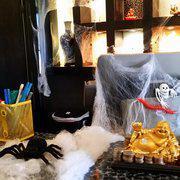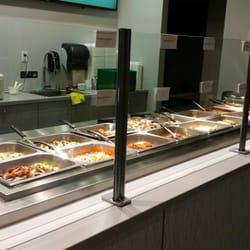The first image is the image on the left, the second image is the image on the right. Examine the images to the left and right. Is the description "The right image shows tongs by rows of steel bins full of food, and the left image includes a white food plate surrounded by other dishware items on a dark table." accurate? Answer yes or no. No. 